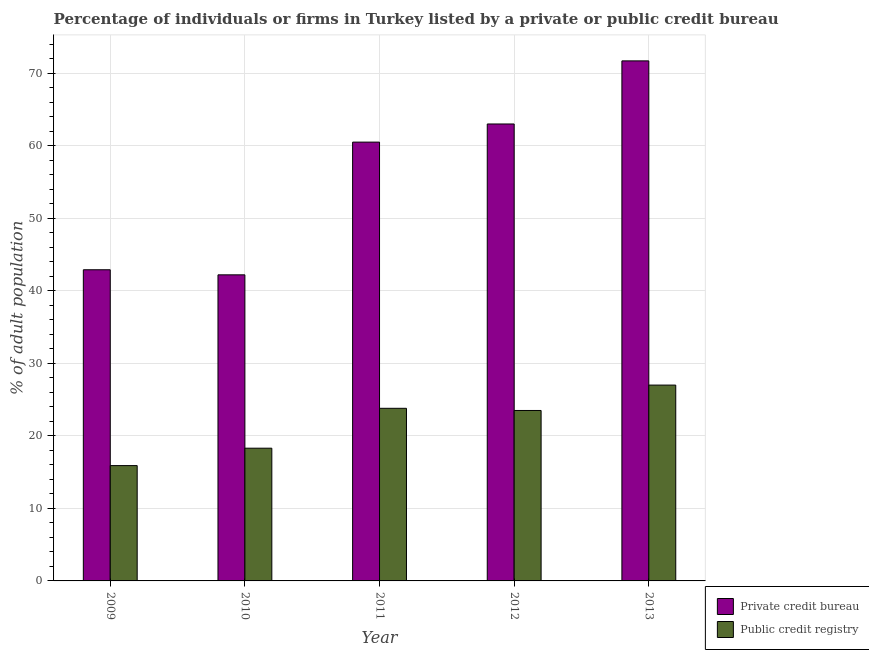How many different coloured bars are there?
Offer a very short reply. 2. Are the number of bars on each tick of the X-axis equal?
Give a very brief answer. Yes. How many bars are there on the 5th tick from the right?
Offer a terse response. 2. What is the label of the 3rd group of bars from the left?
Your response must be concise. 2011. In how many cases, is the number of bars for a given year not equal to the number of legend labels?
Your response must be concise. 0. What is the percentage of firms listed by private credit bureau in 2013?
Make the answer very short. 71.7. Across all years, what is the minimum percentage of firms listed by private credit bureau?
Offer a very short reply. 42.2. In which year was the percentage of firms listed by public credit bureau maximum?
Provide a short and direct response. 2013. In which year was the percentage of firms listed by public credit bureau minimum?
Your response must be concise. 2009. What is the total percentage of firms listed by private credit bureau in the graph?
Ensure brevity in your answer.  280.3. What is the difference between the percentage of firms listed by public credit bureau in 2009 and that in 2010?
Give a very brief answer. -2.4. What is the difference between the percentage of firms listed by public credit bureau in 2012 and the percentage of firms listed by private credit bureau in 2010?
Offer a terse response. 5.2. What is the average percentage of firms listed by private credit bureau per year?
Offer a very short reply. 56.06. What is the ratio of the percentage of firms listed by private credit bureau in 2011 to that in 2013?
Provide a succinct answer. 0.84. Is the percentage of firms listed by public credit bureau in 2009 less than that in 2012?
Give a very brief answer. Yes. What is the difference between the highest and the second highest percentage of firms listed by public credit bureau?
Your answer should be compact. 3.2. What is the difference between the highest and the lowest percentage of firms listed by private credit bureau?
Your response must be concise. 29.5. In how many years, is the percentage of firms listed by private credit bureau greater than the average percentage of firms listed by private credit bureau taken over all years?
Your answer should be very brief. 3. What does the 1st bar from the left in 2010 represents?
Your answer should be compact. Private credit bureau. What does the 2nd bar from the right in 2009 represents?
Give a very brief answer. Private credit bureau. How many bars are there?
Provide a short and direct response. 10. How many years are there in the graph?
Keep it short and to the point. 5. What is the difference between two consecutive major ticks on the Y-axis?
Your response must be concise. 10. Are the values on the major ticks of Y-axis written in scientific E-notation?
Your response must be concise. No. Does the graph contain any zero values?
Your answer should be compact. No. Does the graph contain grids?
Offer a very short reply. Yes. How many legend labels are there?
Offer a terse response. 2. How are the legend labels stacked?
Make the answer very short. Vertical. What is the title of the graph?
Make the answer very short. Percentage of individuals or firms in Turkey listed by a private or public credit bureau. Does "IMF concessional" appear as one of the legend labels in the graph?
Ensure brevity in your answer.  No. What is the label or title of the X-axis?
Give a very brief answer. Year. What is the label or title of the Y-axis?
Ensure brevity in your answer.  % of adult population. What is the % of adult population of Private credit bureau in 2009?
Keep it short and to the point. 42.9. What is the % of adult population of Public credit registry in 2009?
Offer a terse response. 15.9. What is the % of adult population in Private credit bureau in 2010?
Provide a succinct answer. 42.2. What is the % of adult population of Private credit bureau in 2011?
Your answer should be compact. 60.5. What is the % of adult population in Public credit registry in 2011?
Provide a short and direct response. 23.8. What is the % of adult population of Public credit registry in 2012?
Your response must be concise. 23.5. What is the % of adult population in Private credit bureau in 2013?
Your answer should be very brief. 71.7. Across all years, what is the maximum % of adult population of Private credit bureau?
Your answer should be very brief. 71.7. Across all years, what is the maximum % of adult population of Public credit registry?
Your response must be concise. 27. Across all years, what is the minimum % of adult population of Private credit bureau?
Your answer should be compact. 42.2. What is the total % of adult population of Private credit bureau in the graph?
Provide a succinct answer. 280.3. What is the total % of adult population in Public credit registry in the graph?
Your answer should be very brief. 108.5. What is the difference between the % of adult population in Private credit bureau in 2009 and that in 2010?
Give a very brief answer. 0.7. What is the difference between the % of adult population of Public credit registry in 2009 and that in 2010?
Your answer should be very brief. -2.4. What is the difference between the % of adult population in Private credit bureau in 2009 and that in 2011?
Provide a short and direct response. -17.6. What is the difference between the % of adult population of Public credit registry in 2009 and that in 2011?
Keep it short and to the point. -7.9. What is the difference between the % of adult population of Private credit bureau in 2009 and that in 2012?
Offer a very short reply. -20.1. What is the difference between the % of adult population of Public credit registry in 2009 and that in 2012?
Give a very brief answer. -7.6. What is the difference between the % of adult population in Private credit bureau in 2009 and that in 2013?
Provide a short and direct response. -28.8. What is the difference between the % of adult population in Public credit registry in 2009 and that in 2013?
Provide a succinct answer. -11.1. What is the difference between the % of adult population of Private credit bureau in 2010 and that in 2011?
Your answer should be very brief. -18.3. What is the difference between the % of adult population of Public credit registry in 2010 and that in 2011?
Your answer should be very brief. -5.5. What is the difference between the % of adult population of Private credit bureau in 2010 and that in 2012?
Keep it short and to the point. -20.8. What is the difference between the % of adult population in Private credit bureau in 2010 and that in 2013?
Your answer should be very brief. -29.5. What is the difference between the % of adult population of Public credit registry in 2010 and that in 2013?
Give a very brief answer. -8.7. What is the difference between the % of adult population in Private credit bureau in 2011 and that in 2012?
Make the answer very short. -2.5. What is the difference between the % of adult population of Public credit registry in 2011 and that in 2013?
Make the answer very short. -3.2. What is the difference between the % of adult population in Private credit bureau in 2012 and that in 2013?
Offer a very short reply. -8.7. What is the difference between the % of adult population in Private credit bureau in 2009 and the % of adult population in Public credit registry in 2010?
Offer a very short reply. 24.6. What is the difference between the % of adult population of Private credit bureau in 2009 and the % of adult population of Public credit registry in 2013?
Keep it short and to the point. 15.9. What is the difference between the % of adult population of Private credit bureau in 2010 and the % of adult population of Public credit registry in 2013?
Your answer should be very brief. 15.2. What is the difference between the % of adult population in Private credit bureau in 2011 and the % of adult population in Public credit registry in 2013?
Make the answer very short. 33.5. What is the difference between the % of adult population of Private credit bureau in 2012 and the % of adult population of Public credit registry in 2013?
Give a very brief answer. 36. What is the average % of adult population of Private credit bureau per year?
Keep it short and to the point. 56.06. What is the average % of adult population in Public credit registry per year?
Ensure brevity in your answer.  21.7. In the year 2010, what is the difference between the % of adult population in Private credit bureau and % of adult population in Public credit registry?
Ensure brevity in your answer.  23.9. In the year 2011, what is the difference between the % of adult population in Private credit bureau and % of adult population in Public credit registry?
Ensure brevity in your answer.  36.7. In the year 2012, what is the difference between the % of adult population in Private credit bureau and % of adult population in Public credit registry?
Offer a very short reply. 39.5. In the year 2013, what is the difference between the % of adult population of Private credit bureau and % of adult population of Public credit registry?
Keep it short and to the point. 44.7. What is the ratio of the % of adult population of Private credit bureau in 2009 to that in 2010?
Your answer should be compact. 1.02. What is the ratio of the % of adult population of Public credit registry in 2009 to that in 2010?
Give a very brief answer. 0.87. What is the ratio of the % of adult population in Private credit bureau in 2009 to that in 2011?
Provide a succinct answer. 0.71. What is the ratio of the % of adult population of Public credit registry in 2009 to that in 2011?
Offer a terse response. 0.67. What is the ratio of the % of adult population of Private credit bureau in 2009 to that in 2012?
Offer a terse response. 0.68. What is the ratio of the % of adult population in Public credit registry in 2009 to that in 2012?
Your response must be concise. 0.68. What is the ratio of the % of adult population in Private credit bureau in 2009 to that in 2013?
Provide a short and direct response. 0.6. What is the ratio of the % of adult population of Public credit registry in 2009 to that in 2013?
Provide a succinct answer. 0.59. What is the ratio of the % of adult population in Private credit bureau in 2010 to that in 2011?
Keep it short and to the point. 0.7. What is the ratio of the % of adult population of Public credit registry in 2010 to that in 2011?
Your answer should be compact. 0.77. What is the ratio of the % of adult population in Private credit bureau in 2010 to that in 2012?
Keep it short and to the point. 0.67. What is the ratio of the % of adult population in Public credit registry in 2010 to that in 2012?
Give a very brief answer. 0.78. What is the ratio of the % of adult population in Private credit bureau in 2010 to that in 2013?
Ensure brevity in your answer.  0.59. What is the ratio of the % of adult population of Public credit registry in 2010 to that in 2013?
Offer a very short reply. 0.68. What is the ratio of the % of adult population of Private credit bureau in 2011 to that in 2012?
Give a very brief answer. 0.96. What is the ratio of the % of adult population in Public credit registry in 2011 to that in 2012?
Your answer should be compact. 1.01. What is the ratio of the % of adult population of Private credit bureau in 2011 to that in 2013?
Make the answer very short. 0.84. What is the ratio of the % of adult population in Public credit registry in 2011 to that in 2013?
Keep it short and to the point. 0.88. What is the ratio of the % of adult population of Private credit bureau in 2012 to that in 2013?
Offer a very short reply. 0.88. What is the ratio of the % of adult population of Public credit registry in 2012 to that in 2013?
Provide a short and direct response. 0.87. What is the difference between the highest and the lowest % of adult population of Private credit bureau?
Provide a short and direct response. 29.5. 